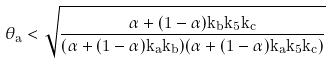Convert formula to latex. <formula><loc_0><loc_0><loc_500><loc_500>\theta _ { a } < \sqrt { \frac { \alpha + ( 1 - \alpha ) k _ { b } k _ { 5 } k _ { c } } { ( \alpha + ( 1 - \alpha ) k _ { a } k _ { b } ) ( \alpha + ( 1 - \alpha ) k _ { a } k _ { 5 } k _ { c } ) } }</formula> 